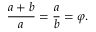<formula> <loc_0><loc_0><loc_500><loc_500>{ \frac { a + b } { a } } = { \frac { a } { b } } = \varphi .</formula> 